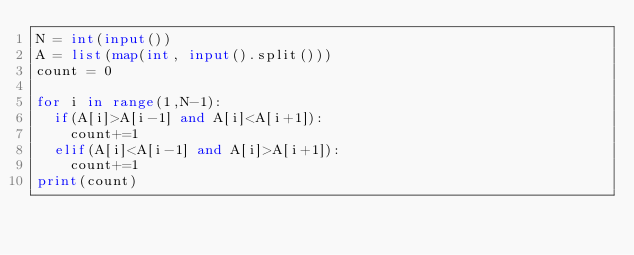<code> <loc_0><loc_0><loc_500><loc_500><_Python_>N = int(input())
A = list(map(int, input().split())) 
count = 0

for i in range(1,N-1):
  if(A[i]>A[i-1] and A[i]<A[i+1]):
    count+=1
  elif(A[i]<A[i-1] and A[i]>A[i+1]):
    count+=1
print(count)</code> 